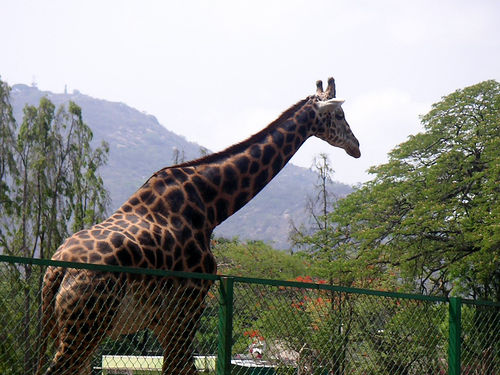How many giraffes are in the image? 1 